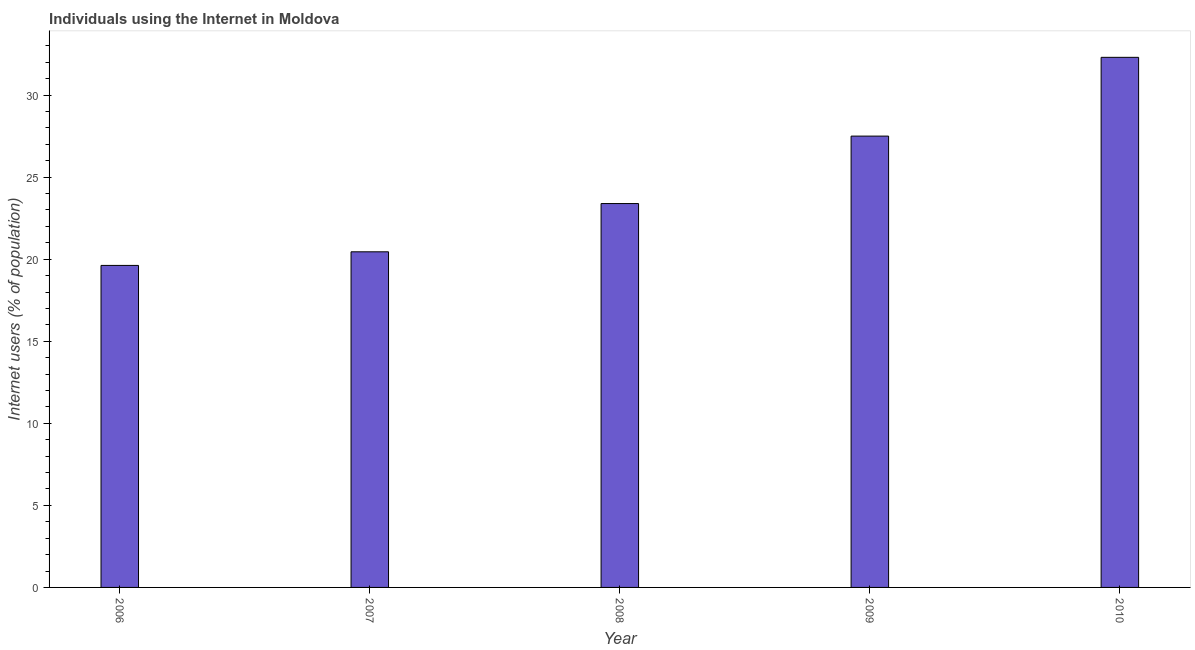What is the title of the graph?
Keep it short and to the point. Individuals using the Internet in Moldova. What is the label or title of the Y-axis?
Make the answer very short. Internet users (% of population). What is the number of internet users in 2006?
Offer a very short reply. 19.62. Across all years, what is the maximum number of internet users?
Your response must be concise. 32.3. Across all years, what is the minimum number of internet users?
Offer a terse response. 19.62. What is the sum of the number of internet users?
Provide a short and direct response. 123.26. What is the difference between the number of internet users in 2008 and 2010?
Give a very brief answer. -8.91. What is the average number of internet users per year?
Your answer should be compact. 24.65. What is the median number of internet users?
Offer a terse response. 23.39. In how many years, is the number of internet users greater than 24 %?
Provide a short and direct response. 2. What is the ratio of the number of internet users in 2009 to that in 2010?
Your answer should be very brief. 0.85. Is the number of internet users in 2006 less than that in 2010?
Offer a very short reply. Yes. What is the difference between the highest and the lowest number of internet users?
Offer a very short reply. 12.68. In how many years, is the number of internet users greater than the average number of internet users taken over all years?
Ensure brevity in your answer.  2. How many years are there in the graph?
Ensure brevity in your answer.  5. What is the difference between two consecutive major ticks on the Y-axis?
Your answer should be compact. 5. Are the values on the major ticks of Y-axis written in scientific E-notation?
Provide a short and direct response. No. What is the Internet users (% of population) of 2006?
Provide a short and direct response. 19.62. What is the Internet users (% of population) in 2007?
Your answer should be very brief. 20.45. What is the Internet users (% of population) in 2008?
Ensure brevity in your answer.  23.39. What is the Internet users (% of population) of 2010?
Offer a terse response. 32.3. What is the difference between the Internet users (% of population) in 2006 and 2007?
Ensure brevity in your answer.  -0.83. What is the difference between the Internet users (% of population) in 2006 and 2008?
Your response must be concise. -3.77. What is the difference between the Internet users (% of population) in 2006 and 2009?
Your answer should be compact. -7.88. What is the difference between the Internet users (% of population) in 2006 and 2010?
Offer a terse response. -12.68. What is the difference between the Internet users (% of population) in 2007 and 2008?
Your answer should be compact. -2.94. What is the difference between the Internet users (% of population) in 2007 and 2009?
Provide a succinct answer. -7.05. What is the difference between the Internet users (% of population) in 2007 and 2010?
Make the answer very short. -11.85. What is the difference between the Internet users (% of population) in 2008 and 2009?
Your answer should be compact. -4.11. What is the difference between the Internet users (% of population) in 2008 and 2010?
Offer a very short reply. -8.91. What is the difference between the Internet users (% of population) in 2009 and 2010?
Your response must be concise. -4.8. What is the ratio of the Internet users (% of population) in 2006 to that in 2007?
Offer a very short reply. 0.96. What is the ratio of the Internet users (% of population) in 2006 to that in 2008?
Offer a terse response. 0.84. What is the ratio of the Internet users (% of population) in 2006 to that in 2009?
Provide a succinct answer. 0.71. What is the ratio of the Internet users (% of population) in 2006 to that in 2010?
Give a very brief answer. 0.61. What is the ratio of the Internet users (% of population) in 2007 to that in 2008?
Your response must be concise. 0.87. What is the ratio of the Internet users (% of population) in 2007 to that in 2009?
Ensure brevity in your answer.  0.74. What is the ratio of the Internet users (% of population) in 2007 to that in 2010?
Make the answer very short. 0.63. What is the ratio of the Internet users (% of population) in 2008 to that in 2009?
Your answer should be very brief. 0.85. What is the ratio of the Internet users (% of population) in 2008 to that in 2010?
Your answer should be very brief. 0.72. What is the ratio of the Internet users (% of population) in 2009 to that in 2010?
Your answer should be compact. 0.85. 